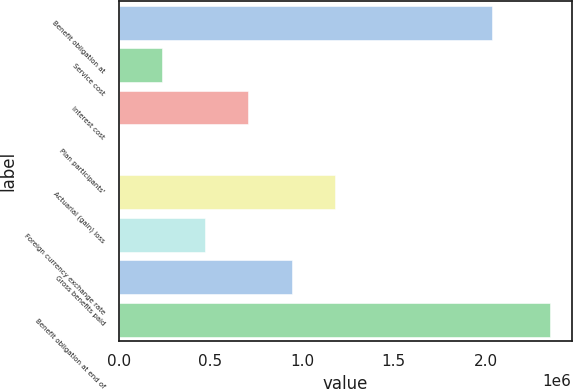Convert chart to OTSL. <chart><loc_0><loc_0><loc_500><loc_500><bar_chart><fcel>Benefit obligation at<fcel>Service cost<fcel>Interest cost<fcel>Plan participants'<fcel>Actuarial (gain) loss<fcel>Foreign currency exchange rate<fcel>Gross benefits paid<fcel>Benefit obligation at end of<nl><fcel>2.03518e+06<fcel>238383<fcel>708096<fcel>3526<fcel>1.17781e+06<fcel>473240<fcel>942953<fcel>2.35209e+06<nl></chart> 